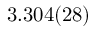<formula> <loc_0><loc_0><loc_500><loc_500>3 . 3 0 4 ( 2 8 )</formula> 